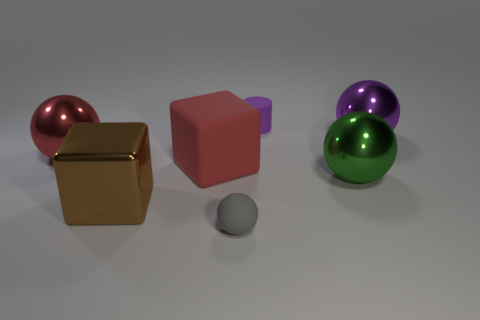What size is the shiny ball that is on the left side of the tiny cylinder?
Offer a terse response. Large. There is a small matte thing on the left side of the small object that is behind the big brown thing; what shape is it?
Your answer should be compact. Sphere. There is a big shiny sphere on the left side of the small rubber thing that is behind the gray ball; how many big red things are on the right side of it?
Give a very brief answer. 1. Are there fewer big shiny spheres to the left of the tiny gray matte thing than small spheres?
Make the answer very short. No. Is there any other thing that has the same shape as the large purple metallic object?
Make the answer very short. Yes. What shape is the red thing that is in front of the big red shiny thing?
Make the answer very short. Cube. There is a large purple metal thing that is behind the metallic sphere to the left of the tiny matte thing that is behind the purple shiny ball; what is its shape?
Your answer should be very brief. Sphere. How many objects are either tiny yellow metal spheres or purple shiny balls?
Ensure brevity in your answer.  1. Does the rubber thing that is in front of the big green object have the same shape as the small object that is behind the big purple sphere?
Your response must be concise. No. What number of objects are both on the left side of the gray sphere and in front of the large green sphere?
Make the answer very short. 1. 